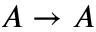Convert formula to latex. <formula><loc_0><loc_0><loc_500><loc_500>A \rightarrow A</formula> 